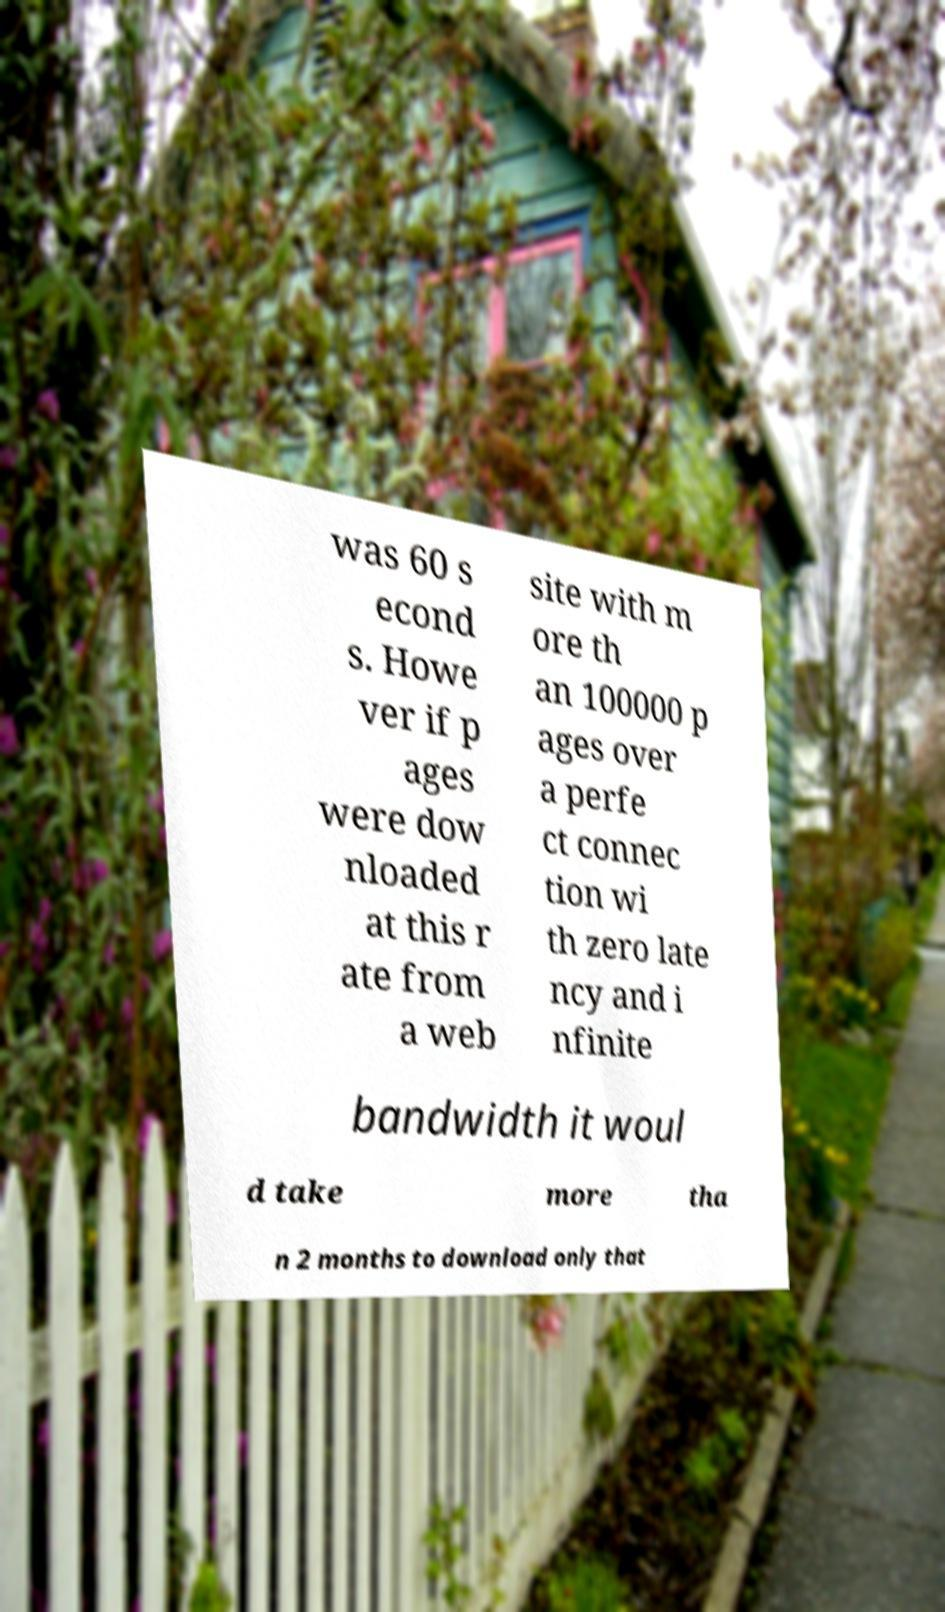Can you accurately transcribe the text from the provided image for me? was 60 s econd s. Howe ver if p ages were dow nloaded at this r ate from a web site with m ore th an 100000 p ages over a perfe ct connec tion wi th zero late ncy and i nfinite bandwidth it woul d take more tha n 2 months to download only that 